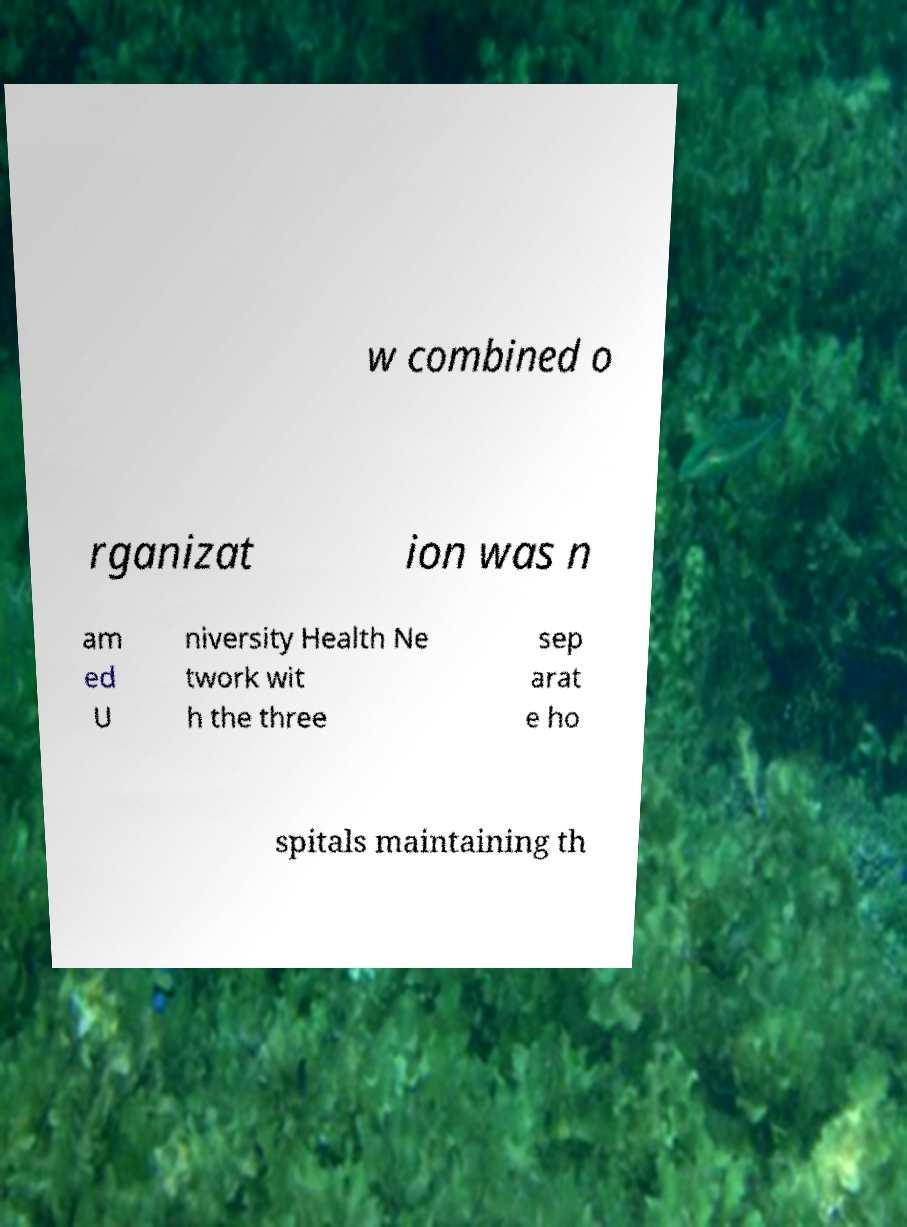I need the written content from this picture converted into text. Can you do that? w combined o rganizat ion was n am ed U niversity Health Ne twork wit h the three sep arat e ho spitals maintaining th 